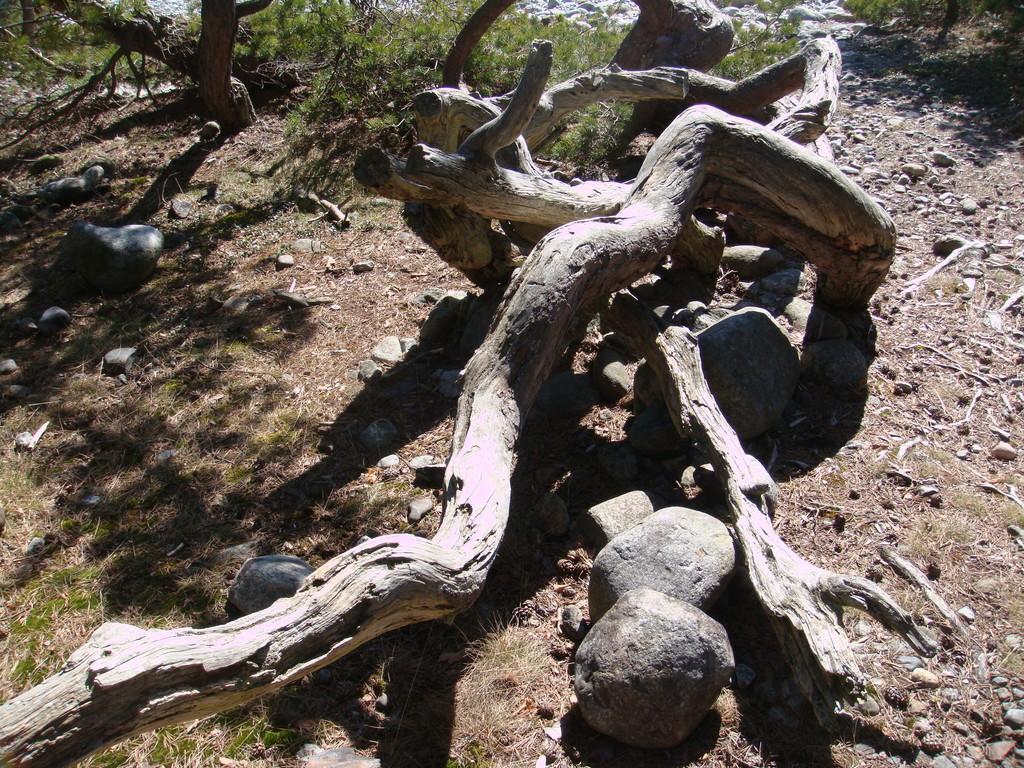In one or two sentences, can you explain what this image depicts? In the center of the image there is a log and we can see stones. In the background there is grass and a tree. 